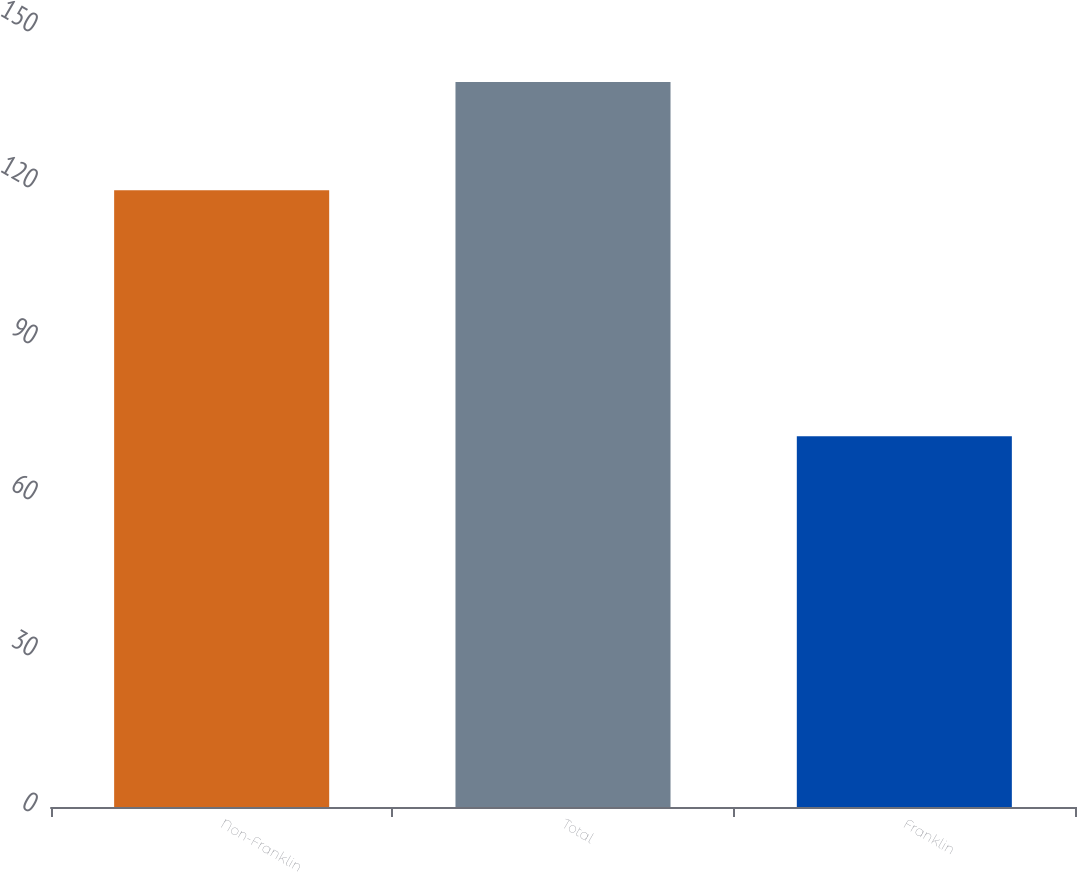Convert chart to OTSL. <chart><loc_0><loc_0><loc_500><loc_500><bar_chart><fcel>Non-Franklin<fcel>Total<fcel>Franklin<nl><fcel>118.6<fcel>139.4<fcel>71.3<nl></chart> 